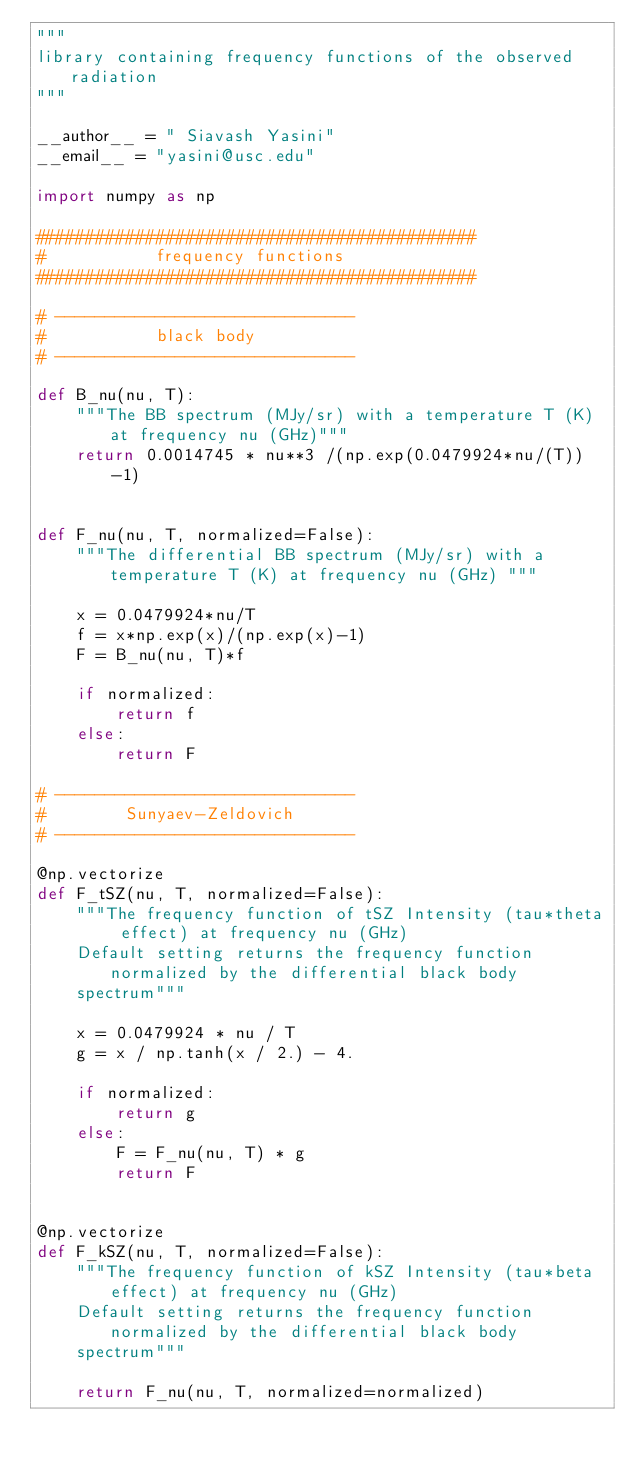Convert code to text. <code><loc_0><loc_0><loc_500><loc_500><_Python_>"""
library containing frequency functions of the observed radiation
"""

__author__ = " Siavash Yasini"
__email__ = "yasini@usc.edu"

import numpy as np

############################################
#           frequency functions
############################################
      
# ------------------------------
#           black body
# ------------------------------

def B_nu(nu, T):
    """The BB spectrum (MJy/sr) with a temperature T (K) at frequency nu (GHz)"""
    return 0.0014745 * nu**3 /(np.exp(0.0479924*nu/(T))-1)


def F_nu(nu, T, normalized=False):
    """The differential BB spectrum (MJy/sr) with a temperature T (K) at frequency nu (GHz) """

    x = 0.0479924*nu/T
    f = x*np.exp(x)/(np.exp(x)-1)
    F = B_nu(nu, T)*f

    if normalized:
        return f
    else:
        return F

# ------------------------------
#        Sunyaev-Zeldovich
# ------------------------------

@np.vectorize
def F_tSZ(nu, T, normalized=False):
    """The frequency function of tSZ Intensity (tau*theta effect) at frequency nu (GHz)
    Default setting returns the frequency function normalized by the differential black body
    spectrum"""

    x = 0.0479924 * nu / T
    g = x / np.tanh(x / 2.) - 4.

    if normalized:
        return g
    else:
        F = F_nu(nu, T) * g
        return F


@np.vectorize
def F_kSZ(nu, T, normalized=False):
    """The frequency function of kSZ Intensity (tau*beta effect) at frequency nu (GHz)
    Default setting returns the frequency function normalized by the differential black body
    spectrum"""

    return F_nu(nu, T, normalized=normalized)
</code> 